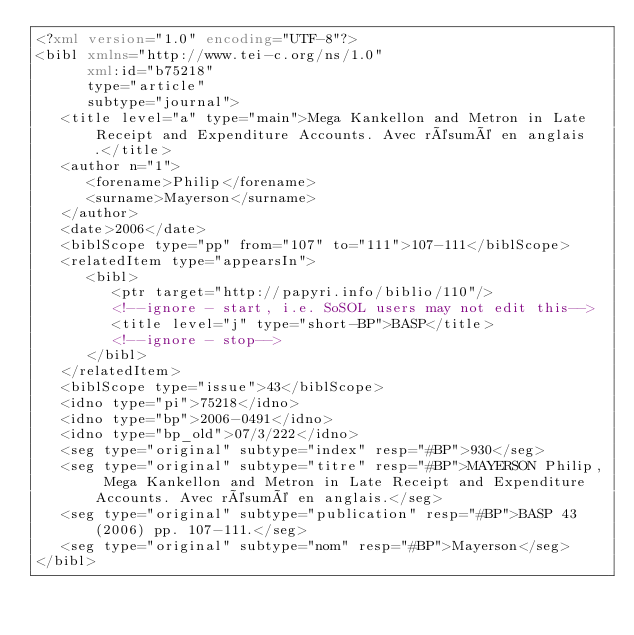<code> <loc_0><loc_0><loc_500><loc_500><_XML_><?xml version="1.0" encoding="UTF-8"?>
<bibl xmlns="http://www.tei-c.org/ns/1.0"
      xml:id="b75218"
      type="article"
      subtype="journal">
   <title level="a" type="main">Mega Kankellon and Metron in Late Receipt and Expenditure Accounts. Avec résumé en anglais.</title>
   <author n="1">
      <forename>Philip</forename>
      <surname>Mayerson</surname>
   </author>
   <date>2006</date>
   <biblScope type="pp" from="107" to="111">107-111</biblScope>
   <relatedItem type="appearsIn">
      <bibl>
         <ptr target="http://papyri.info/biblio/110"/>
         <!--ignore - start, i.e. SoSOL users may not edit this-->
         <title level="j" type="short-BP">BASP</title>
         <!--ignore - stop-->
      </bibl>
   </relatedItem>
   <biblScope type="issue">43</biblScope>
   <idno type="pi">75218</idno>
   <idno type="bp">2006-0491</idno>
   <idno type="bp_old">07/3/222</idno>
   <seg type="original" subtype="index" resp="#BP">930</seg>
   <seg type="original" subtype="titre" resp="#BP">MAYERSON Philip, Mega Kankellon and Metron in Late Receipt and Expenditure Accounts. Avec résumé en anglais.</seg>
   <seg type="original" subtype="publication" resp="#BP">BASP 43 (2006) pp. 107-111.</seg>
   <seg type="original" subtype="nom" resp="#BP">Mayerson</seg>
</bibl>
</code> 